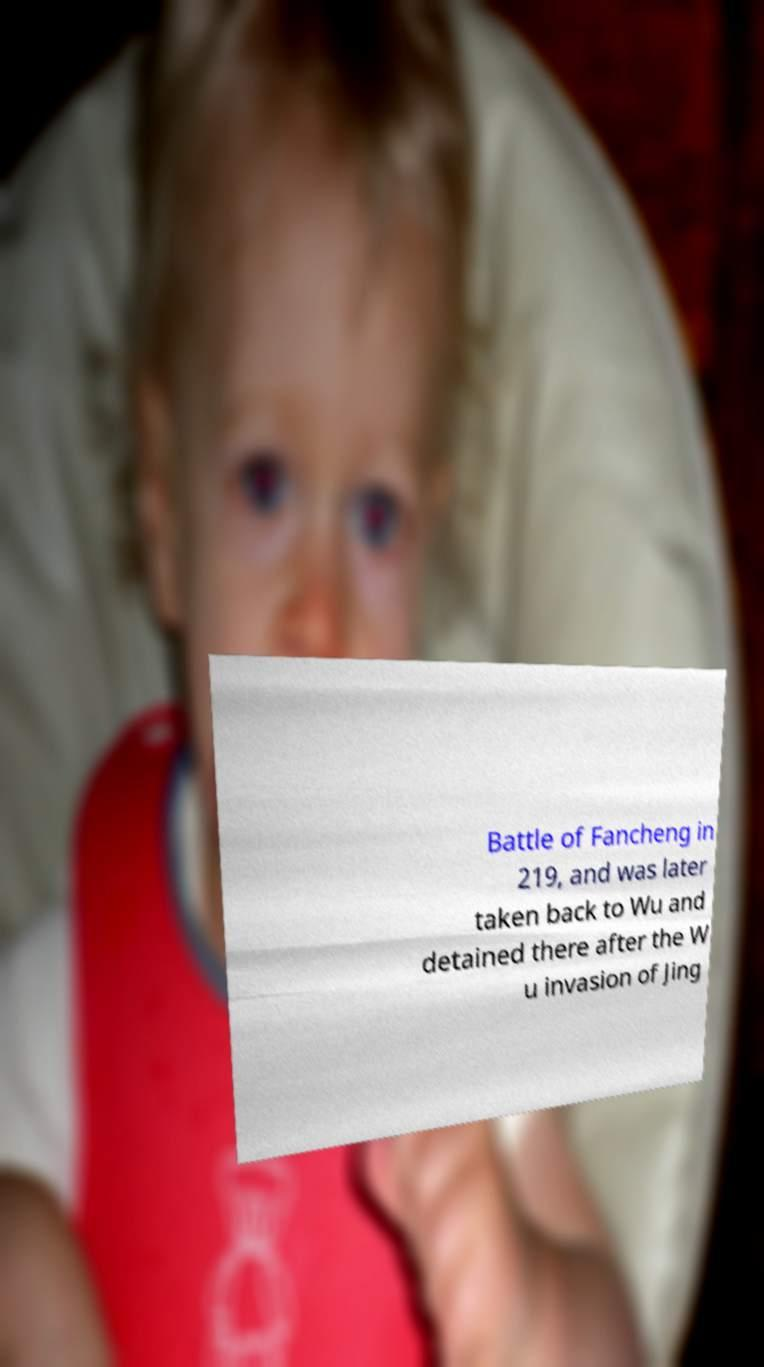Can you read and provide the text displayed in the image?This photo seems to have some interesting text. Can you extract and type it out for me? Battle of Fancheng in 219, and was later taken back to Wu and detained there after the W u invasion of Jing 